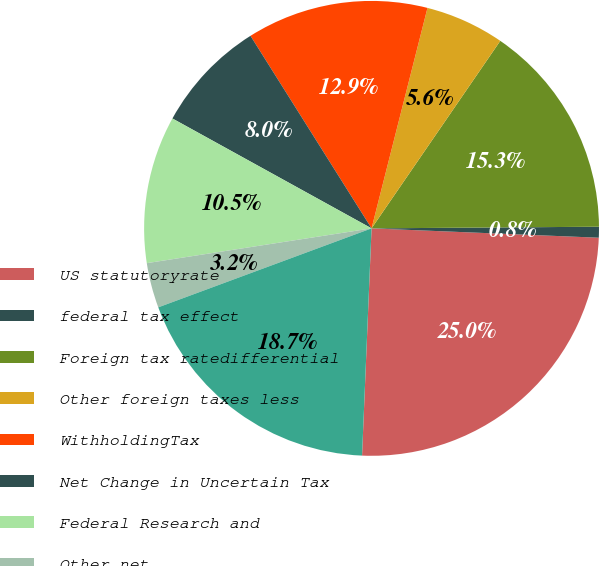Convert chart. <chart><loc_0><loc_0><loc_500><loc_500><pie_chart><fcel>US statutoryrate<fcel>federal tax effect<fcel>Foreign tax ratedifferential<fcel>Other foreign taxes less<fcel>WithholdingTax<fcel>Net Change in Uncertain Tax<fcel>Federal Research and<fcel>Other net<fcel>Incometax expense (benefit)<nl><fcel>25.01%<fcel>0.77%<fcel>15.31%<fcel>5.62%<fcel>12.89%<fcel>8.04%<fcel>10.47%<fcel>3.2%<fcel>18.69%<nl></chart> 